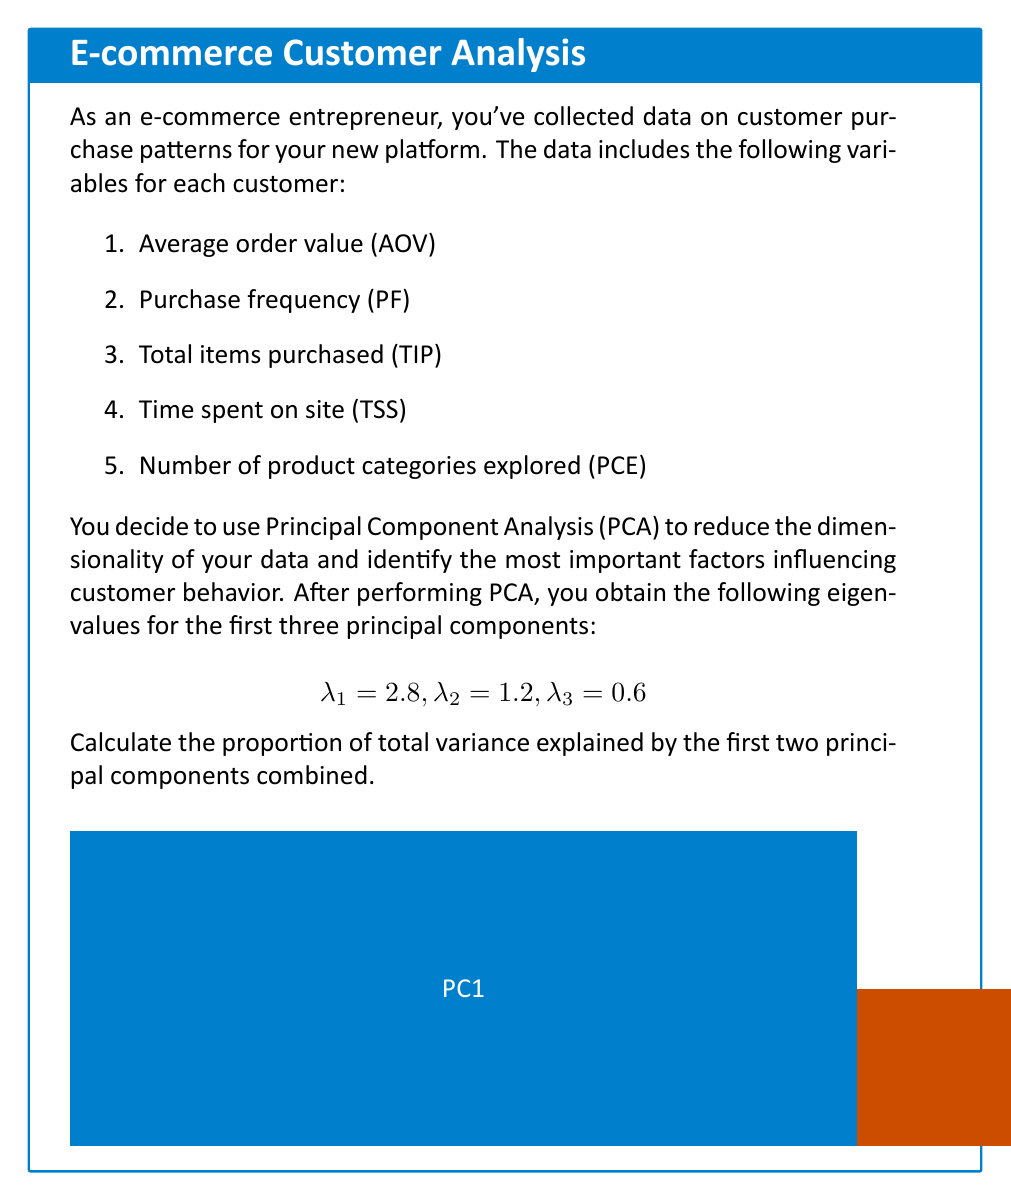Solve this math problem. To solve this problem, we'll follow these steps:

1) First, recall that in PCA, the eigenvalues represent the amount of variance explained by each principal component.

2) The total variance in the dataset is equal to the sum of all eigenvalues. In this case, we're given the first three, but we know there are five variables in total. However, we only need the sum of the given eigenvalues for this calculation:

   $$\text{Total given variance} = \lambda_1 + \lambda_2 + \lambda_3 = 2.8 + 1.2 + 0.6 = 4.6$$

3) The variance explained by the first two principal components is the sum of their eigenvalues:

   $$\text{Variance explained by PC1 and PC2} = \lambda_1 + \lambda_2 = 2.8 + 1.2 = 4.0$$

4) To calculate the proportion of total variance explained by the first two principal components, we divide the variance explained by these components by the total variance:

   $$\text{Proportion} = \frac{\text{Variance explained by PC1 and PC2}}{\text{Total given variance}} = \frac{4.0}{4.6}$$

5) Converting to a percentage:

   $$\text{Percentage} = \frac{4.0}{4.6} \times 100\% \approx 86.96\%$$

Therefore, the first two principal components explain approximately 86.96% of the total variance in the given data.
Answer: 86.96% 